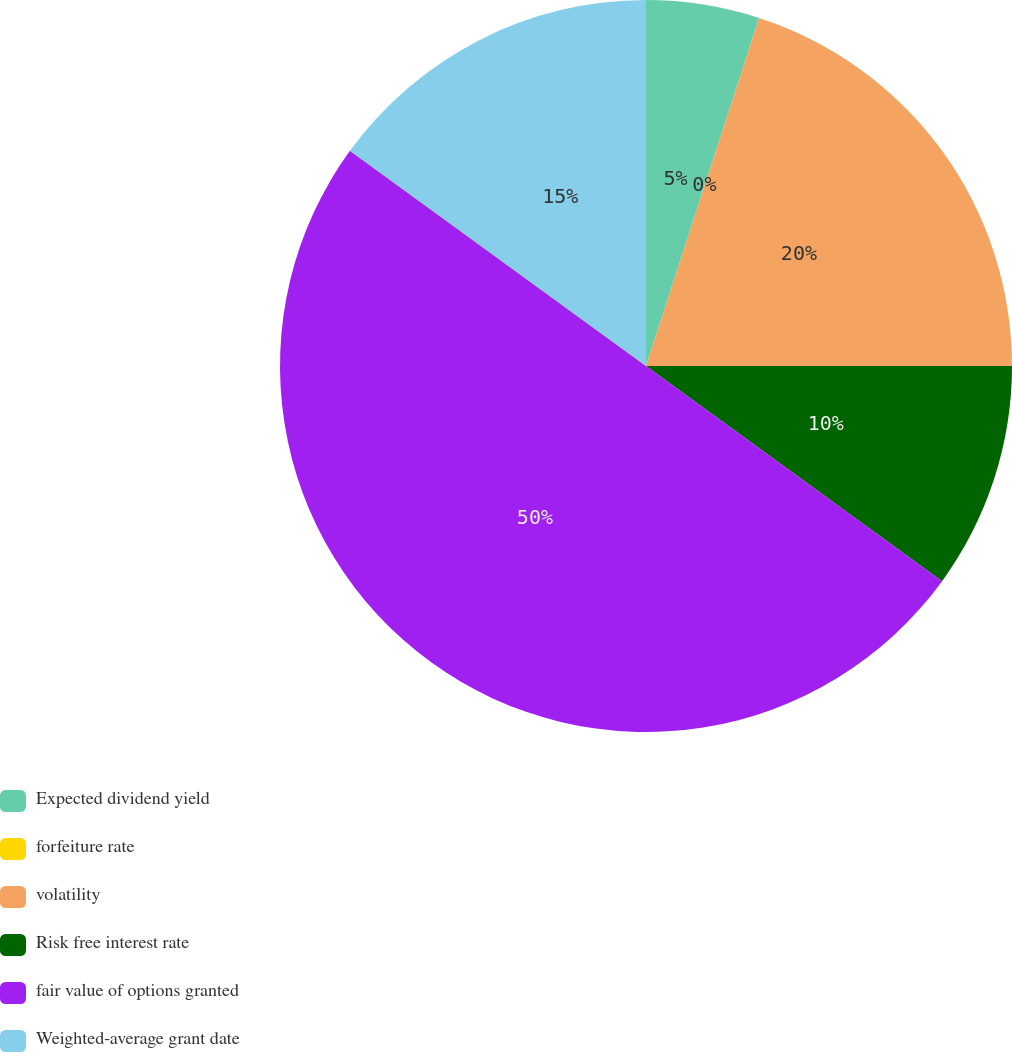<chart> <loc_0><loc_0><loc_500><loc_500><pie_chart><fcel>Expected dividend yield<fcel>forfeiture rate<fcel>volatility<fcel>Risk free interest rate<fcel>fair value of options granted<fcel>Weighted-average grant date<nl><fcel>5.0%<fcel>0.0%<fcel>20.0%<fcel>10.0%<fcel>50.0%<fcel>15.0%<nl></chart> 